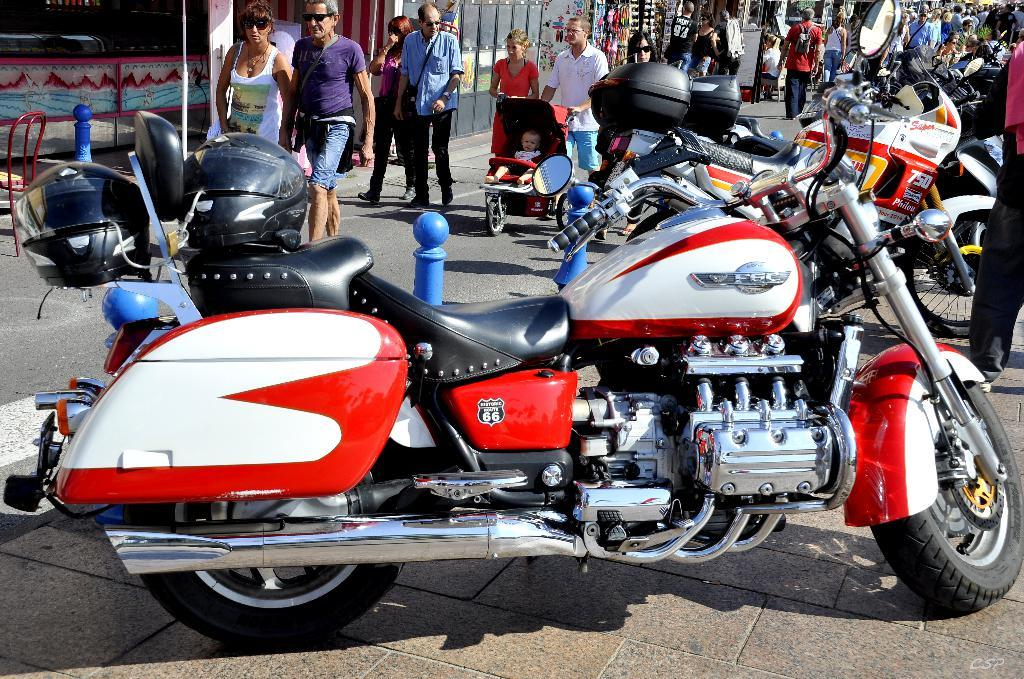<image>
Offer a succinct explanation of the picture presented. Motorcycle with Red and White colors that has the text saying Route 66 on the side. 